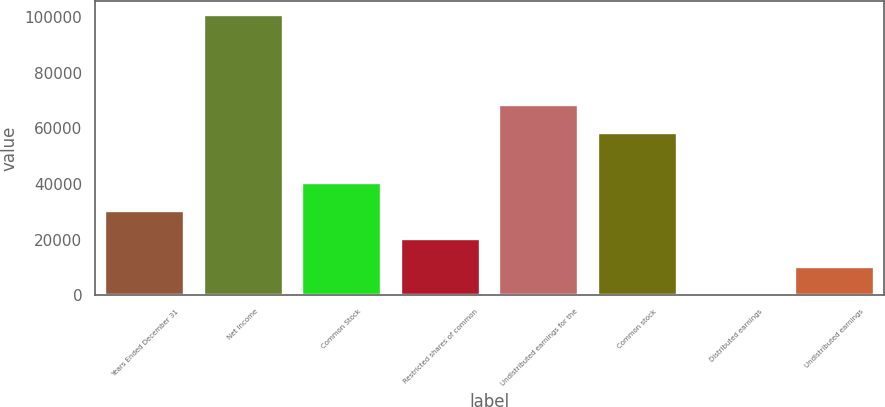Convert chart. <chart><loc_0><loc_0><loc_500><loc_500><bar_chart><fcel>Years Ended December 31<fcel>Net Income<fcel>Common Stock<fcel>Restricted shares of common<fcel>Undistributed earnings for the<fcel>Common stock<fcel>Distributed earnings<fcel>Undistributed earnings<nl><fcel>30213.5<fcel>100711<fcel>40383<fcel>20142.4<fcel>68568.1<fcel>58497<fcel>0.28<fcel>10071.4<nl></chart> 